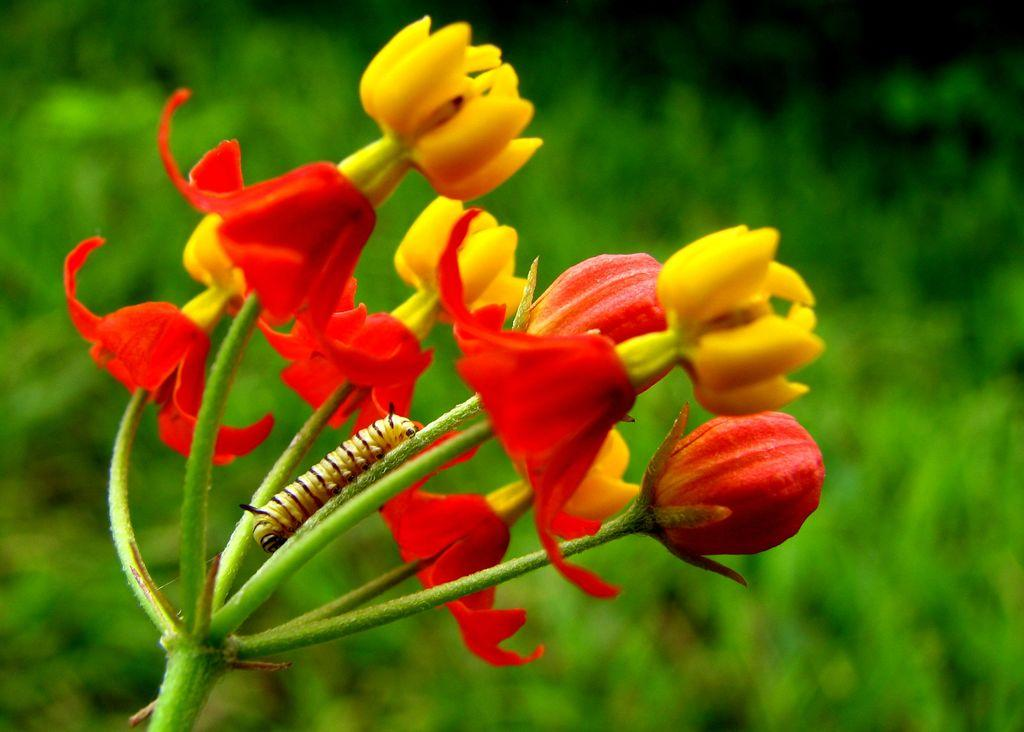What is present on the plant in the image? There is an insect on a plant in the image. What colors are the flowers on the plant? The plant has red and yellow color flowers. What can be seen in the background of the image? There are other plants visible in the background of the image. How many goats are visible in the image? There are no goats present in the image. What type of birds can be seen flying in the image? There are no birds visible in the image. 